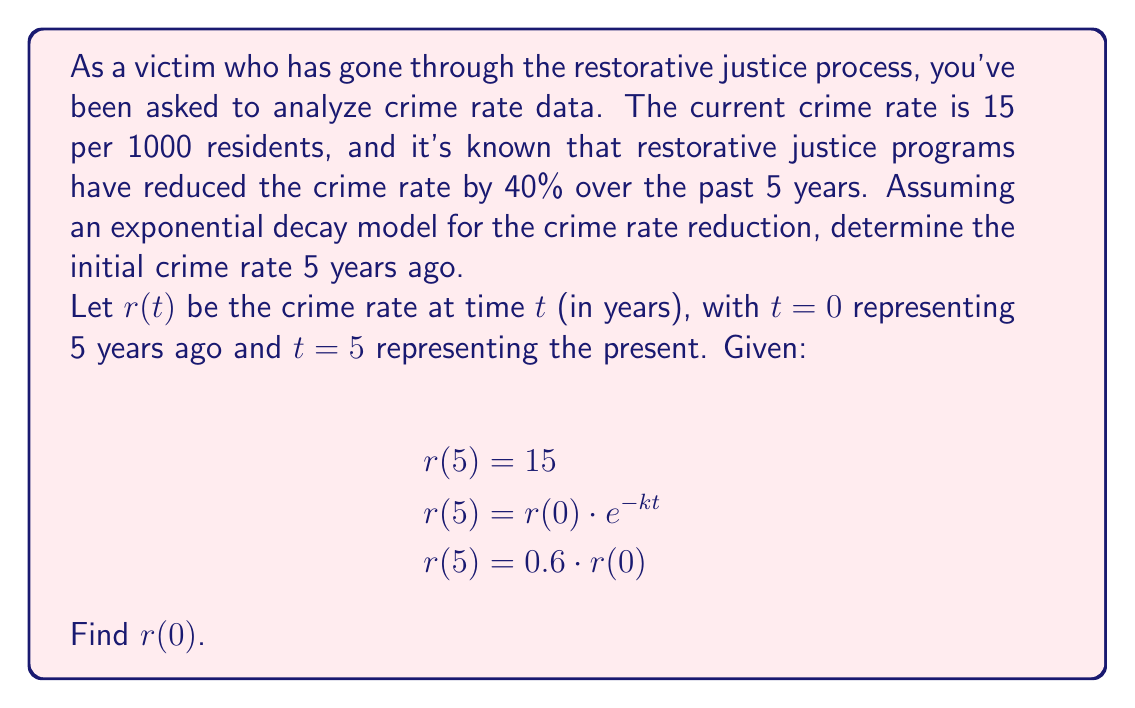Can you solve this math problem? Let's approach this step-by-step:

1) We're given that the current crime rate $r(5) = 15$ per 1000 residents.

2) We know that the crime rate has been reduced by 40%, which means the current rate is 60% of the initial rate:

   $r(5) = 0.6 \cdot r(0)$

3) We can set up the equation:

   $15 = 0.6 \cdot r(0)$

4) To solve for $r(0)$, we divide both sides by 0.6:

   $r(0) = \frac{15}{0.6} = 25$

5) We can verify this using the exponential decay model:

   $r(t) = r(0) \cdot e^{-kt}$

   Where $k$ is the decay constant. We can find $k$ using:

   $0.6 = e^{-5k}$
   $\ln(0.6) = -5k$
   $k = -\frac{\ln(0.6)}{5} \approx 0.1022$

6) Plugging this back into the original equation:

   $r(5) = 25 \cdot e^{-0.1022 \cdot 5} \approx 15$

This confirms our solution.
Answer: $r(0) = 25$ per 1000 residents 